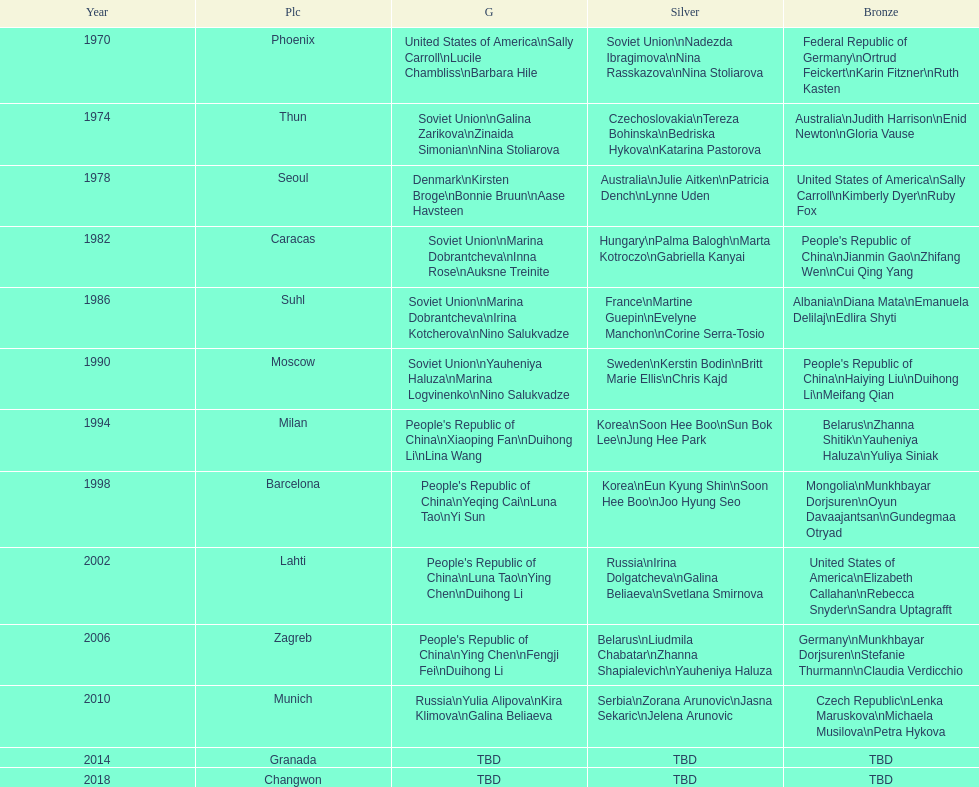What are the total number of times the soviet union is listed under the gold column? 4. 